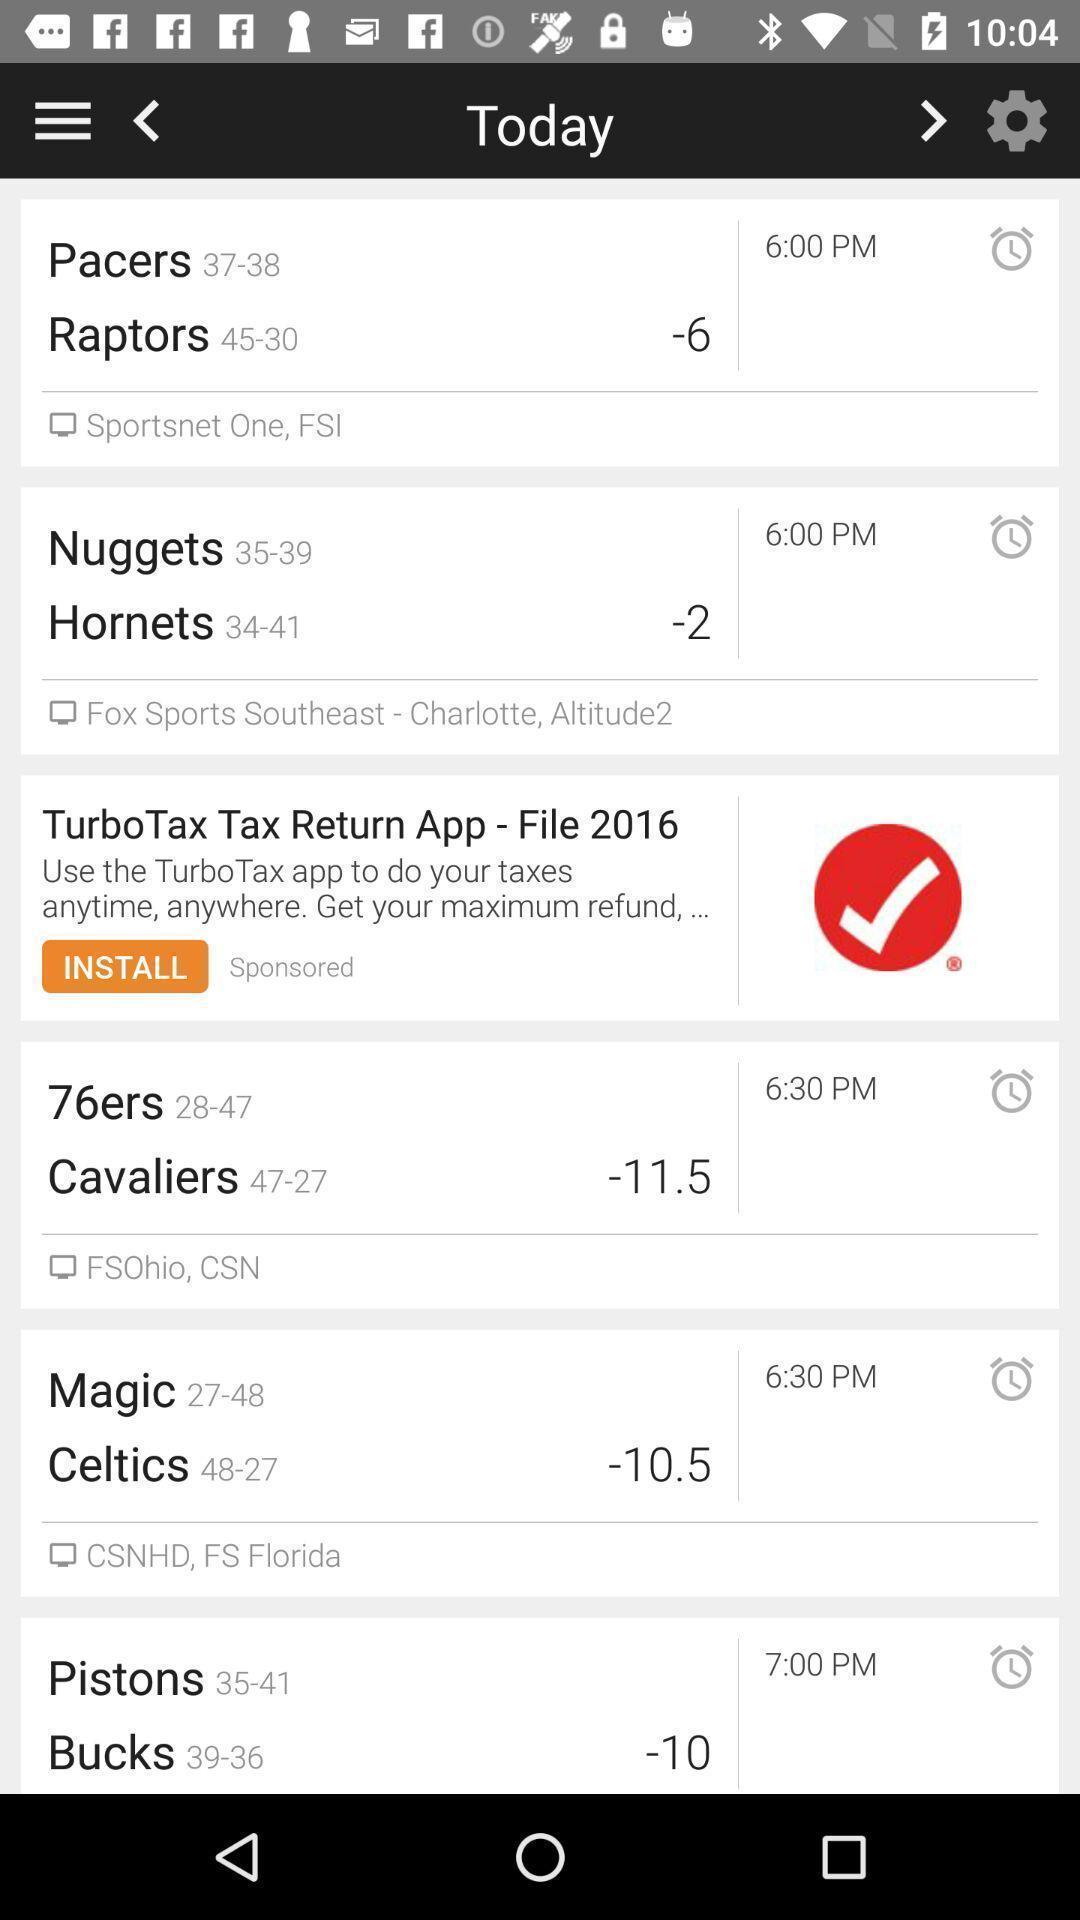What can you discern from this picture? Page shows the results for today in a gaming application. 